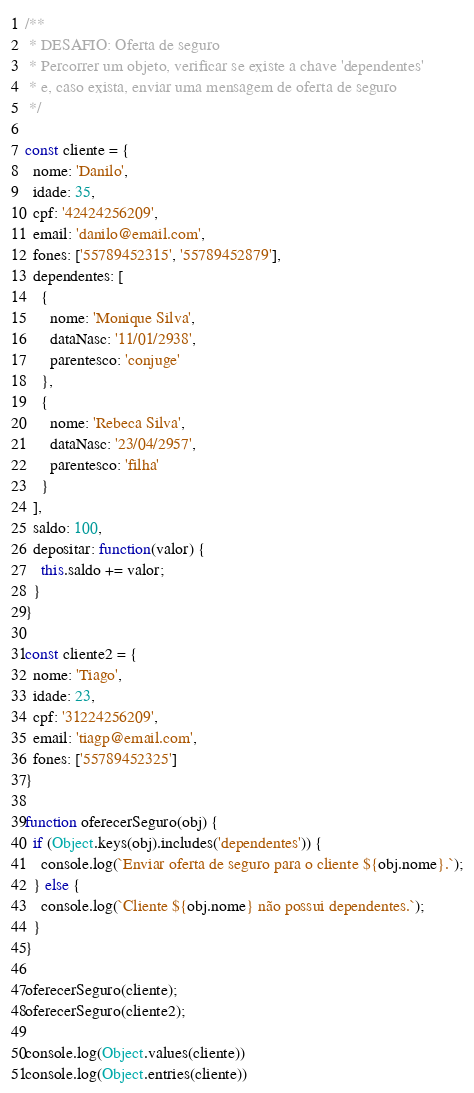Convert code to text. <code><loc_0><loc_0><loc_500><loc_500><_JavaScript_>/**
 * DESAFIO: Oferta de seguro
 * Percorrer um objeto, verificar se existe a chave 'dependentes'
 * e, caso exista, enviar uma mensagem de oferta de seguro
 */

const cliente = {
  nome: 'Danilo',
  idade: 35,
  cpf: '42424256209',
  email: 'danilo@email.com',
  fones: ['55789452315', '55789452879'],
  dependentes: [
    {
      nome: 'Monique Silva',
      dataNasc: '11/01/2938',
      parentesco: 'conjuge'
    },
    {
      nome: 'Rebeca Silva',
      dataNasc: '23/04/2957',
      parentesco: 'filha'
    }
  ],
  saldo: 100,
  depositar: function(valor) {
    this.saldo += valor;
  }
}

const cliente2 = {
  nome: 'Tiago',
  idade: 23,
  cpf: '31224256209',
  email: 'tiagp@email.com',
  fones: ['55789452325']
}

function oferecerSeguro(obj) {
  if (Object.keys(obj).includes('dependentes')) {
    console.log(`Enviar oferta de seguro para o cliente ${obj.nome}.`);
  } else {
    console.log(`Cliente ${obj.nome} não possui dependentes.`);
  }
}

oferecerSeguro(cliente);
oferecerSeguro(cliente2);

console.log(Object.values(cliente))
console.log(Object.entries(cliente))
</code> 